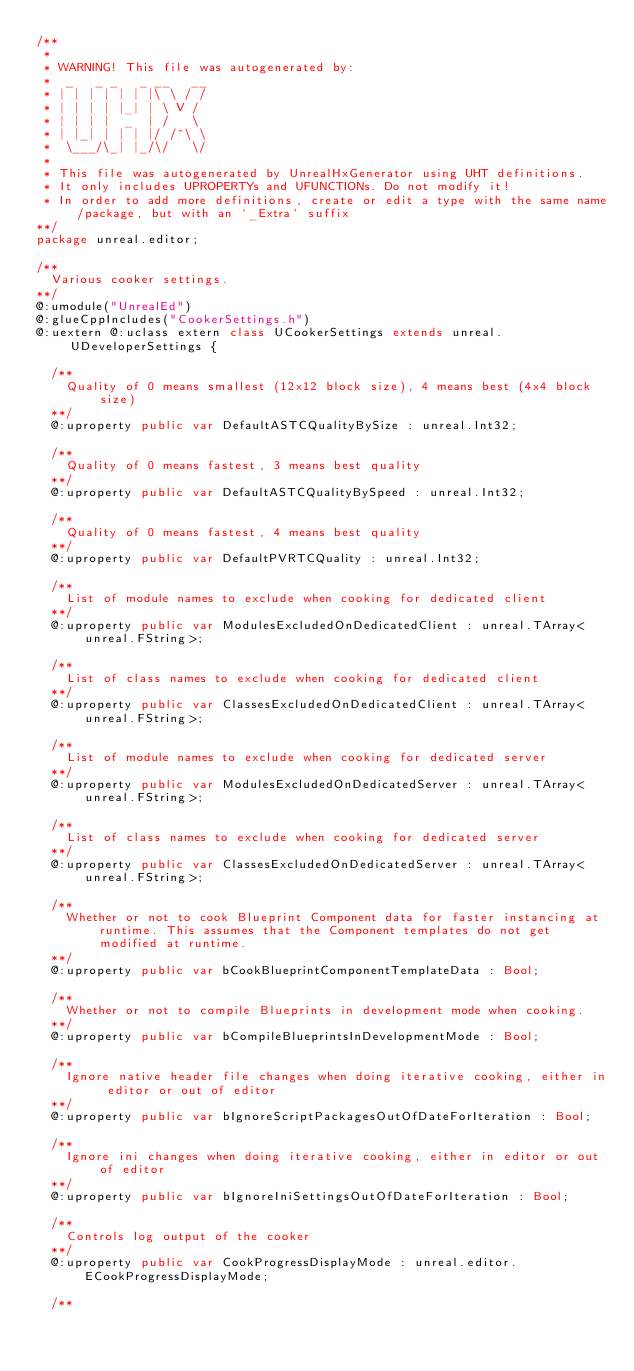<code> <loc_0><loc_0><loc_500><loc_500><_Haxe_>/**
 * 
 * WARNING! This file was autogenerated by: 
 *  _   _ _   _ __   __ 
 * | | | | | | |\ \ / / 
 * | | | | |_| | \ V /  
 * | | | |  _  | /   \  
 * | |_| | | | |/ /^\ \ 
 *  \___/\_| |_/\/   \/ 
 * 
 * This file was autogenerated by UnrealHxGenerator using UHT definitions.
 * It only includes UPROPERTYs and UFUNCTIONs. Do not modify it!
 * In order to add more definitions, create or edit a type with the same name/package, but with an `_Extra` suffix
**/
package unreal.editor;

/**
  Various cooker settings.
**/
@:umodule("UnrealEd")
@:glueCppIncludes("CookerSettings.h")
@:uextern @:uclass extern class UCookerSettings extends unreal.UDeveloperSettings {
  
  /**
    Quality of 0 means smallest (12x12 block size), 4 means best (4x4 block size)
  **/
  @:uproperty public var DefaultASTCQualityBySize : unreal.Int32;
  
  /**
    Quality of 0 means fastest, 3 means best quality
  **/
  @:uproperty public var DefaultASTCQualityBySpeed : unreal.Int32;
  
  /**
    Quality of 0 means fastest, 4 means best quality
  **/
  @:uproperty public var DefaultPVRTCQuality : unreal.Int32;
  
  /**
    List of module names to exclude when cooking for dedicated client
  **/
  @:uproperty public var ModulesExcludedOnDedicatedClient : unreal.TArray<unreal.FString>;
  
  /**
    List of class names to exclude when cooking for dedicated client
  **/
  @:uproperty public var ClassesExcludedOnDedicatedClient : unreal.TArray<unreal.FString>;
  
  /**
    List of module names to exclude when cooking for dedicated server
  **/
  @:uproperty public var ModulesExcludedOnDedicatedServer : unreal.TArray<unreal.FString>;
  
  /**
    List of class names to exclude when cooking for dedicated server
  **/
  @:uproperty public var ClassesExcludedOnDedicatedServer : unreal.TArray<unreal.FString>;
  
  /**
    Whether or not to cook Blueprint Component data for faster instancing at runtime. This assumes that the Component templates do not get modified at runtime.
  **/
  @:uproperty public var bCookBlueprintComponentTemplateData : Bool;
  
  /**
    Whether or not to compile Blueprints in development mode when cooking.
  **/
  @:uproperty public var bCompileBlueprintsInDevelopmentMode : Bool;
  
  /**
    Ignore native header file changes when doing iterative cooking, either in editor or out of editor
  **/
  @:uproperty public var bIgnoreScriptPackagesOutOfDateForIteration : Bool;
  
  /**
    Ignore ini changes when doing iterative cooking, either in editor or out of editor
  **/
  @:uproperty public var bIgnoreIniSettingsOutOfDateForIteration : Bool;
  
  /**
    Controls log output of the cooker
  **/
  @:uproperty public var CookProgressDisplayMode : unreal.editor.ECookProgressDisplayMode;
  
  /**</code> 